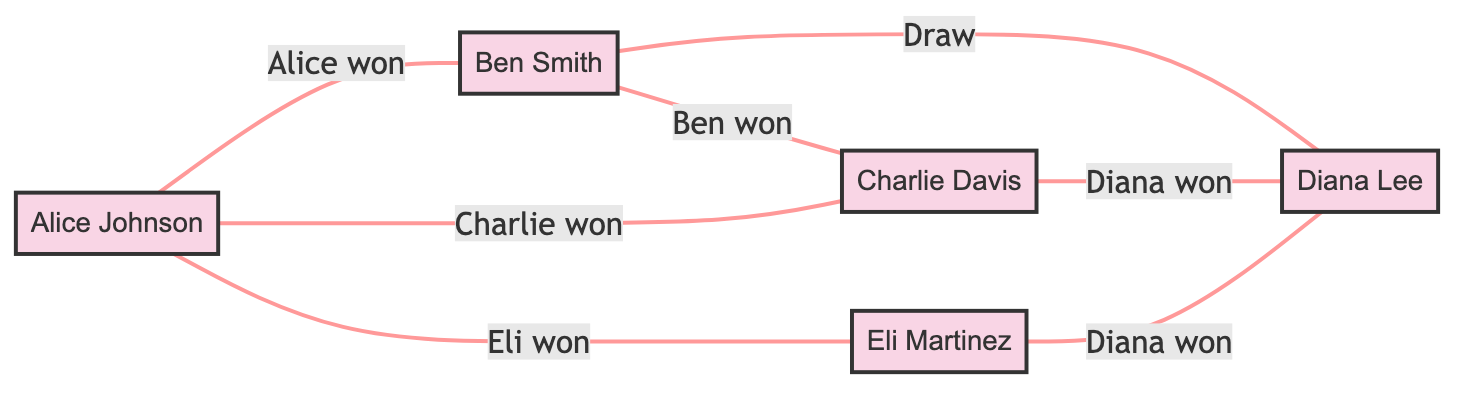What is the total number of members in the chess club? The diagram lists the members as Alice Johnson, Ben Smith, Charlie Davis, Diana Lee, and Eli Martinez. Counting these names gives us a total of 5 members.
Answer: 5 Which player did Alice Johnson lose to? From the diagram, we can see that Alice played against Charlie Davis, and the result stated is "Charlie won," meaning Alice Johnson lost to Charlie.
Answer: Charlie Davis How many games did Ben Smith play in total? In the diagram, Ben Smith has connections to three players: Alice Johnson, Diana Lee, and Charlie Davis. Therefore, counting these games, Ben Smith participated in a total of 3 games.
Answer: 3 What was the result of the game between Ben Smith and Diana Lee? The diagram shows that Ben Smith and Diana Lee are connected, and the relationship states "Draw," which indicates that the game between them ended in a draw.
Answer: Draw Which player won the most games based on the diagram? Analyzing the results for each player: Alice won 1, Charlie won 1, Ben won 1, and Diana won 2 games. Eli won 1 game. By counting the wins, Diana is the only player with the most wins.
Answer: Diana Lee How many edges are there in the graph? The edges represent the games played, which are directly listed in the diagram's connections. There are 7 connections (or edges) shown between the players, indicating the total number of games played.
Answer: 7 Which player faced a draw in their match? The only match that showed a result of "Draw" is between Ben Smith and Diana Lee. This means that Ben Smith is the player who faced a draw in the diagram.
Answer: Ben Smith How many players won against Diana Lee? Looking at the diagram, we can see two connections to Diana Lee: she won against Charlie Davis and Eli Martinez won against her. Therefore, only Eli Martinez won against Diana Lee once.
Answer: 1 